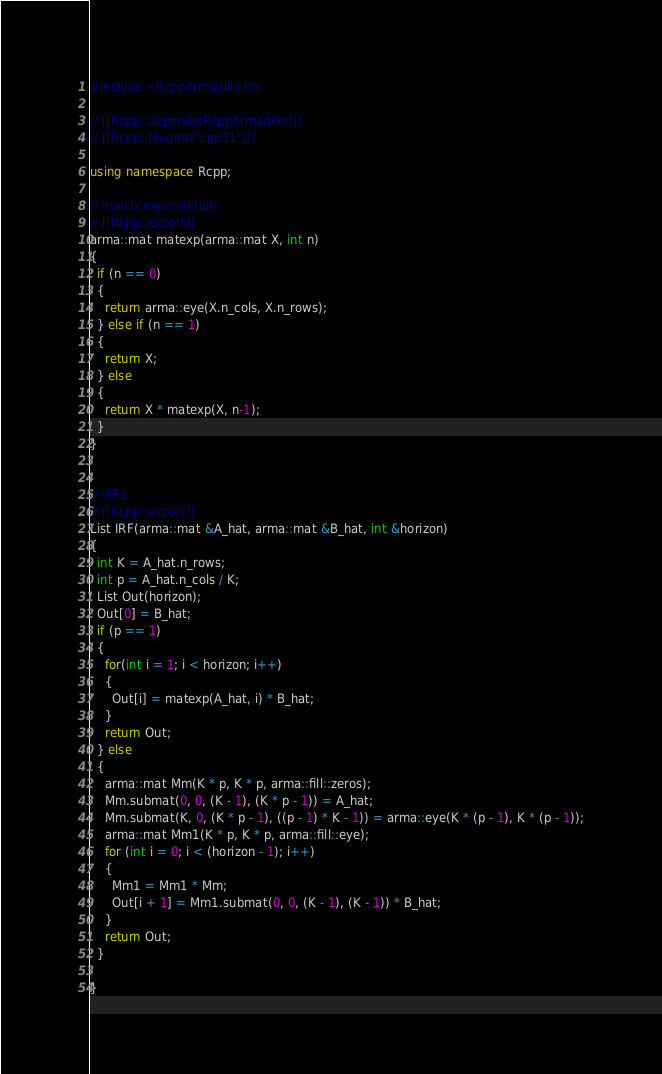Convert code to text. <code><loc_0><loc_0><loc_500><loc_500><_C++_>#include <RcppArmadillo.h>

// [[Rcpp::depends(RcppArmadillo)]]
// [[Rcpp::plugins("cpp11")]]

using namespace Rcpp;

// matrix exponentials
// [[Rcpp::export]]
arma::mat matexp(arma::mat X, int n)
{
  if (n == 0)
  {
    return arma::eye(X.n_cols, X.n_rows);
  } else if (n == 1)
  {
    return X;
  } else
  {
    return X * matexp(X, n-1);
  }
}


// IRFs
// [[Rcpp::export]]
List IRF(arma::mat &A_hat, arma::mat &B_hat, int &horizon)
{
  int K = A_hat.n_rows;
  int p = A_hat.n_cols / K;
  List Out(horizon);
  Out[0] = B_hat;
  if (p == 1)
  {
    for(int i = 1; i < horizon; i++)
    {
      Out[i] = matexp(A_hat, i) * B_hat;
    }
    return Out;
  } else
  {
    arma::mat Mm(K * p, K * p, arma::fill::zeros);
    Mm.submat(0, 0, (K - 1), (K * p - 1)) = A_hat;
    Mm.submat(K, 0, (K * p - 1), ((p - 1) * K - 1)) = arma::eye(K * (p - 1), K * (p - 1));
    arma::mat Mm1(K * p, K * p, arma::fill::eye);
    for (int i = 0; i < (horizon - 1); i++)
    {
      Mm1 = Mm1 * Mm;
      Out[i + 1] = Mm1.submat(0, 0, (K - 1), (K - 1)) * B_hat;
    }
    return Out;
  }

}
</code> 